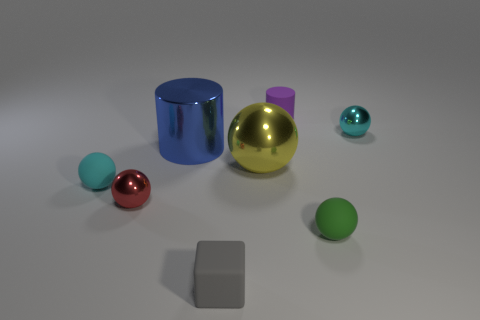There is another tiny rubber thing that is the same shape as the green matte object; what is its color?
Offer a very short reply. Cyan. Is the number of things left of the cyan rubber object greater than the number of large yellow things?
Provide a succinct answer. No. There is a metallic cylinder that is behind the gray matte cube; what is its color?
Your answer should be compact. Blue. Does the blue metallic cylinder have the same size as the green rubber ball?
Give a very brief answer. No. The metallic cylinder has what size?
Provide a short and direct response. Large. Are there more small brown matte spheres than metallic balls?
Give a very brief answer. No. The tiny shiny thing in front of the cyan object right of the tiny matte object that is behind the tiny cyan matte object is what color?
Provide a short and direct response. Red. Do the shiny object that is right of the small green object and the large blue metal thing have the same shape?
Your answer should be compact. No. What is the color of the other rubber ball that is the same size as the green matte sphere?
Your answer should be compact. Cyan. How many things are there?
Make the answer very short. 8. 